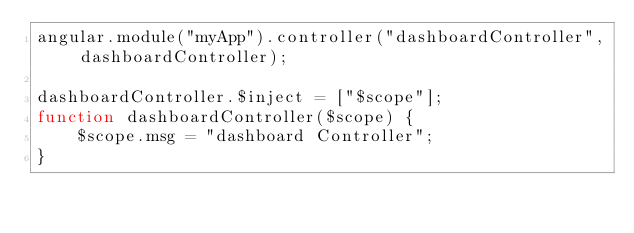<code> <loc_0><loc_0><loc_500><loc_500><_JavaScript_>angular.module("myApp").controller("dashboardController", dashboardController);

dashboardController.$inject = ["$scope"];
function dashboardController($scope) {
    $scope.msg = "dashboard Controller";
}
</code> 